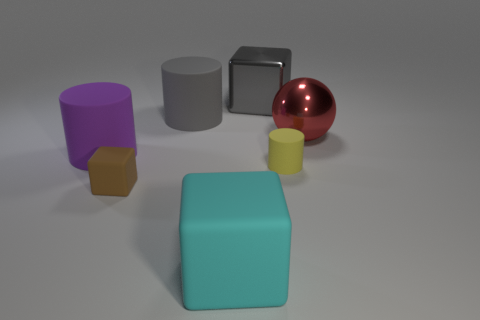Is the number of big cyan objects to the right of the large gray cylinder the same as the number of large spheres that are to the left of the purple object?
Your answer should be compact. No. There is a large thing that is in front of the brown rubber thing; does it have the same shape as the yellow thing?
Your answer should be very brief. No. There is a large purple rubber thing that is left of the big matte thing in front of the purple thing behind the yellow rubber cylinder; what is its shape?
Your response must be concise. Cylinder. There is a large thing that is the same color as the big shiny cube; what shape is it?
Offer a terse response. Cylinder. There is a block that is in front of the large gray cube and on the right side of the big gray cylinder; what is its material?
Offer a terse response. Rubber. Are there fewer big green matte objects than gray metallic blocks?
Give a very brief answer. Yes. Do the large gray matte object and the tiny matte object that is on the left side of the cyan block have the same shape?
Make the answer very short. No. There is a cylinder that is left of the gray rubber object; does it have the same size as the small yellow rubber object?
Offer a very short reply. No. There is a red shiny thing that is the same size as the purple matte object; what shape is it?
Your answer should be very brief. Sphere. Does the large red shiny thing have the same shape as the cyan object?
Your answer should be very brief. No. 